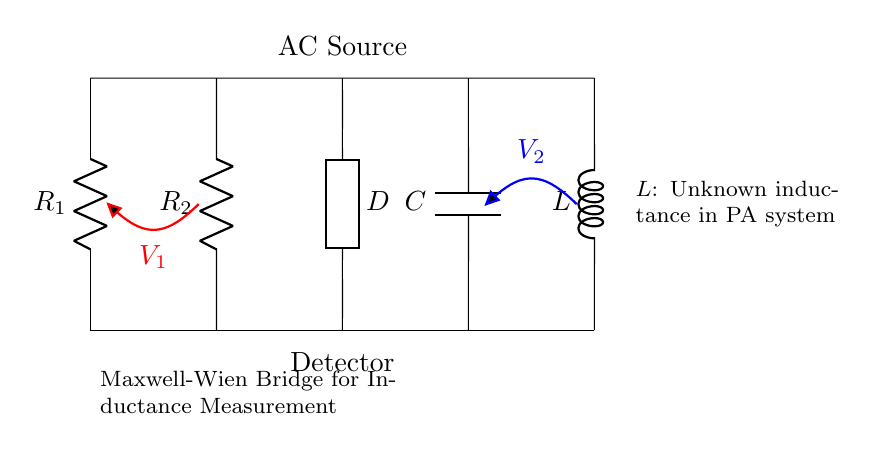What components are present in the circuit? The circuit contains resistors, a capacitor, an inductor, a generic component, an AC source, and a detector. These are identifiable by their labels in the diagram.
Answer: resistors, capacitor, inductor, generic component, AC source, detector What is the purpose of the generic component labeled D? The generic component D is typically a detector used to measure the balance condition or a specific measurement in the Maxwell-Wien Bridge circuit. This component plays a critical role in determining the inductance.
Answer: detector How many resistors are in the circuit? The circuit contains two resistors labeled R1 and R2. Both are indicated in the diagram and clearly marked.
Answer: two What is the role of the inductor labeled L in the circuit? The inductor L represents the unknown inductance in the PA system components that the bridge aims to measure. It is the primary variable we want to determine.
Answer: unknown inductance Which type of circuit is represented by this diagram? This diagram represents a Maxwell-Wien Bridge circuit, which is specifically designed for measuring inductance. It is identified by its particular arrangement and components used.
Answer: Maxwell-Wien Bridge What is the voltage labeled V1 associated with? The voltage V1 is associated with the segment of the circuit where the first resistor R1 and the AC source are connected. It indicates the potential difference across that section.
Answer: first resistor What does the AC source do in the circuit? The AC source provides the alternating current necessary for the operation of the bridge circuit. It enables the measurement by allowing the circuit to oscillate and create a balance condition.
Answer: provide alternating current 